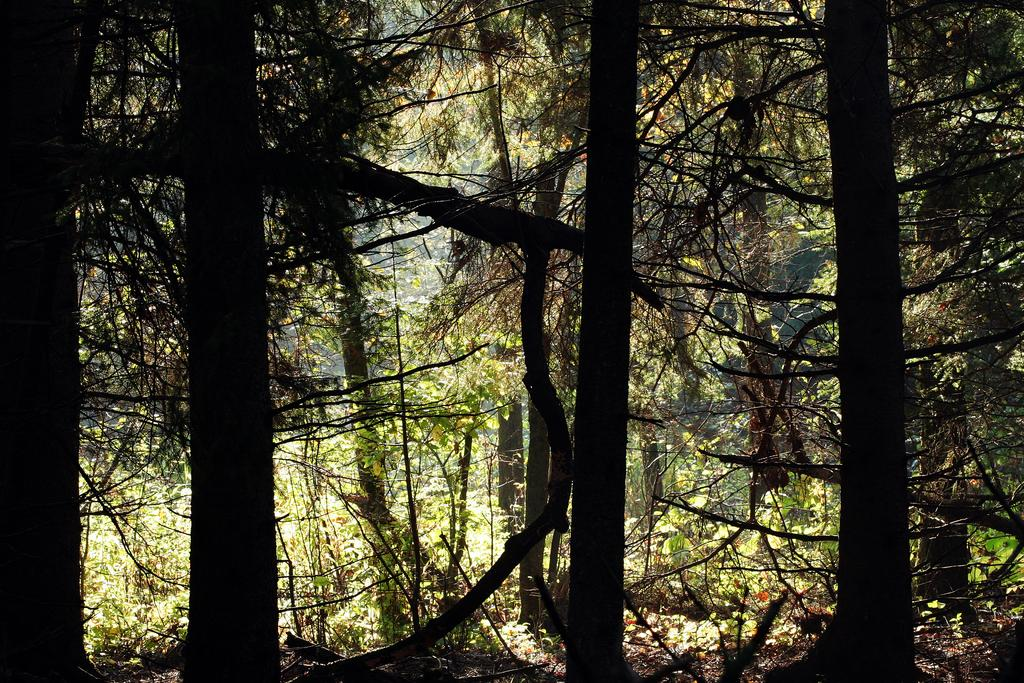What type of location might the image have been taken in? The image might have been clicked in a forest. What type of vegetation can be seen in the image? There are trees and plants in the image. What is present on the ground in the image? Dry leaves are present in the image. What is the weather like in the image? The sun is shining in the image, suggesting a sunny day. How many zebras can be seen grazing in the image? There are no zebras present in the image. What type of seed is being planted by the sheep in the image? There are no sheep or seeds present in the image. 